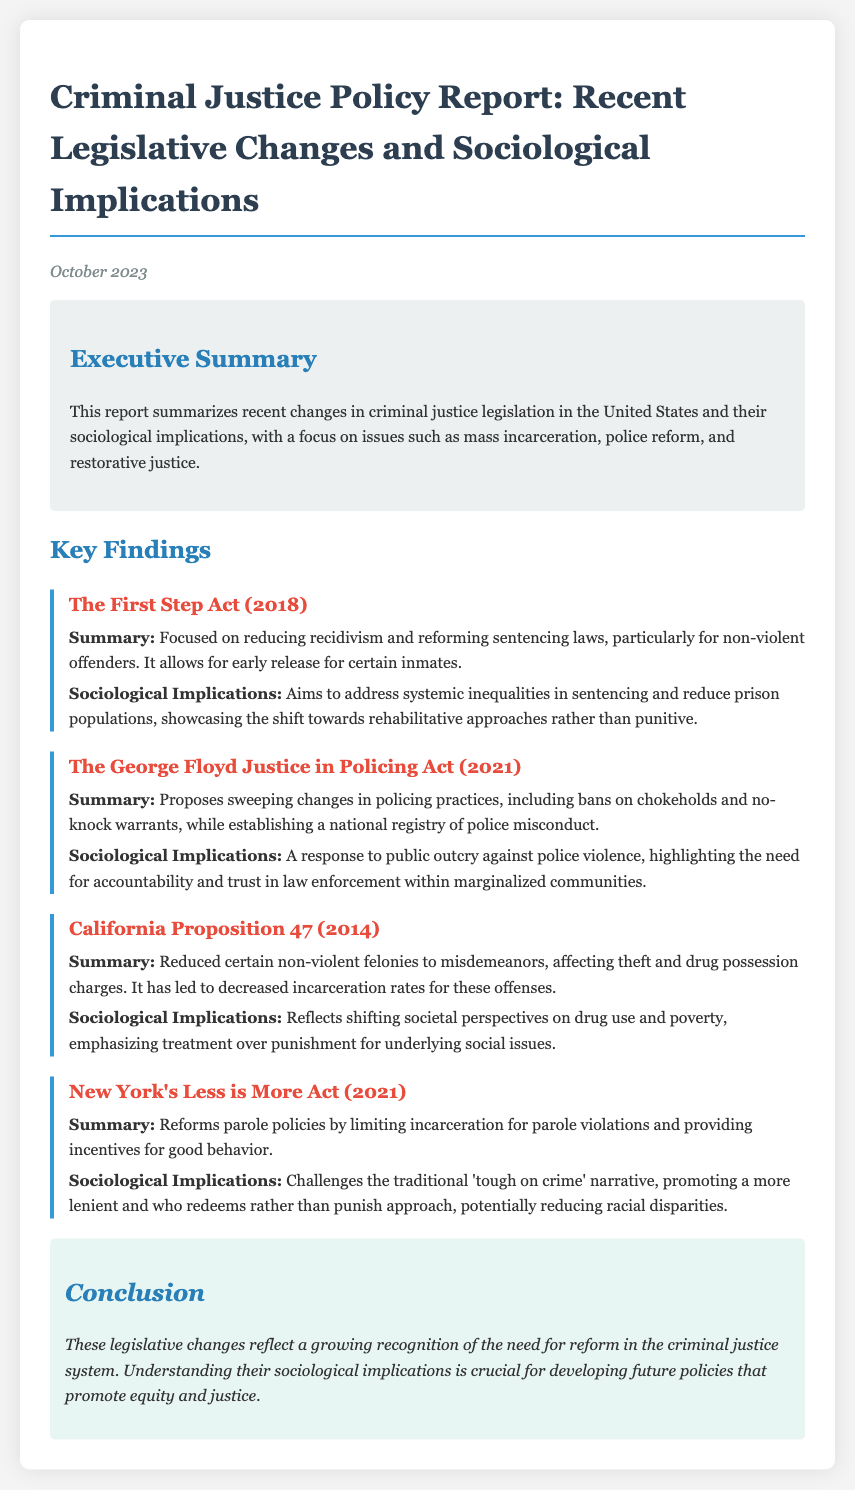What is the focus of The First Step Act? The First Step Act focuses on reducing recidivism and reforming sentencing laws, particularly for non-violent offenders.
Answer: Reducing recidivism What year was The George Floyd Justice in Policing Act proposed? The document specifies that The George Floyd Justice in Policing Act was proposed in 2021.
Answer: 2021 What does California Proposition 47 aim to change? California Proposition 47 aims to reduce certain non-violent felonies to misdemeanors.
Answer: Reduce felonies to misdemeanors What sociological issue does the New York's Less is More Act address? The New York's Less is More Act addresses the issue of traditional 'tough on crime' narratives and promotes leniency.
Answer: Traditional narratives How does the report classify the overarching theme of recent legislative changes? The report classifies the overarching theme as a growing recognition of the need for reform in the criminal justice system.
Answer: Need for reform What is the date of the report? The date of the report is stated as October 2023.
Answer: October 2023 Which act proposes bans on chokeholds and no-knock warrants? The George Floyd Justice in Policing Act proposes bans on chokeholds and no-knock warrants.
Answer: The George Floyd Justice in Policing Act What is a key goal of California Proposition 47? A key goal of California Proposition 47 is to decrease incarceration rates for non-violent offenses.
Answer: Decrease incarceration rates What sociological implication is highlighted in the discussion of The First Step Act? The sociological implication highlighted is addressing systemic inequalities in sentencing.
Answer: Addressing systemic inequalities 